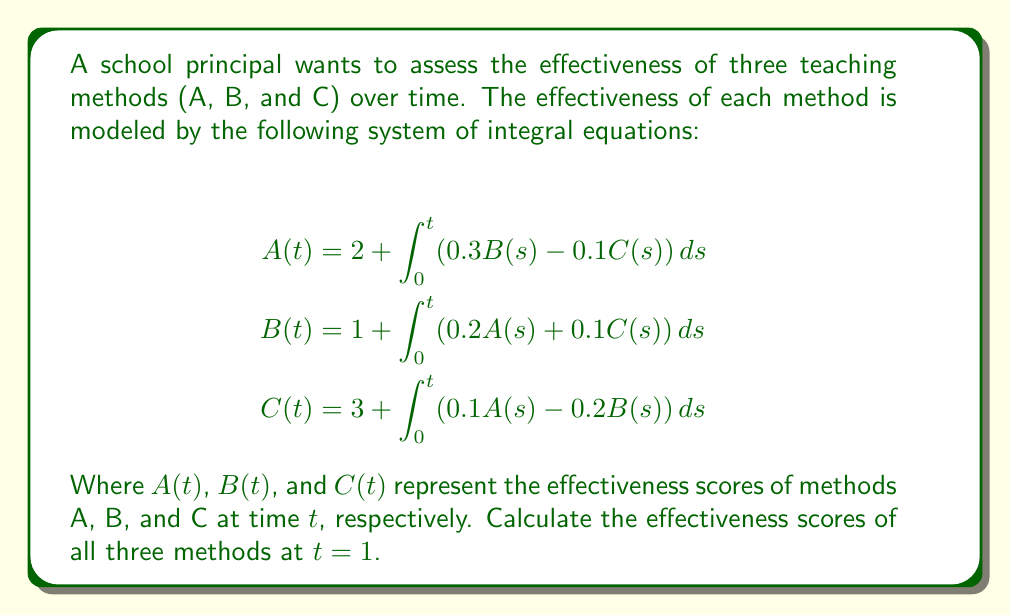Give your solution to this math problem. To solve this system of integral equations, we'll use the following steps:

1) First, we need to differentiate both sides of each equation with respect to $t$:

   $$\begin{align*}
   A'(t) &= 0.3B(t) - 0.1C(t) \\
   B'(t) &= 0.2A(t) + 0.1C(t) \\
   C'(t) &= 0.1A(t) - 0.2B(t)
   \end{align*}$$

2) Now we have a system of differential equations. We can solve this using numerical methods such as Euler's method or Runge-Kutta. Let's use Euler's method with a step size of 0.1.

3) The initial conditions at $t=0$ are:
   $A(0) = 2$, $B(0) = 1$, $C(0) = 3$

4) Euler's method formula: $y_{n+1} = y_n + h \cdot f(t_n, y_n)$, where $h = 0.1$ is our step size.

5) We'll calculate 10 steps to reach $t = 1$:

   Step 1 ($t = 0.1$):
   $$\begin{align*}
   A(0.1) &= 2 + 0.1(0.3 \cdot 1 - 0.1 \cdot 3) = 1.97 \\
   B(0.1) &= 1 + 0.1(0.2 \cdot 2 + 0.1 \cdot 3) = 1.07 \\
   C(0.1) &= 3 + 0.1(0.1 \cdot 2 - 0.2 \cdot 1) = 3
   \end{align*}$$

   We continue this process for the remaining 9 steps.

6) After 10 steps, we get the final values at $t = 1$:
   $A(1) \approx 1.8911$
   $B(1) \approx 1.3162$
   $C(1) \approx 2.9749$

These values represent the effectiveness scores of methods A, B, and C at time $t = 1$.
Answer: $A(1) \approx 1.89$, $B(1) \approx 1.32$, $C(1) \approx 2.97$ 